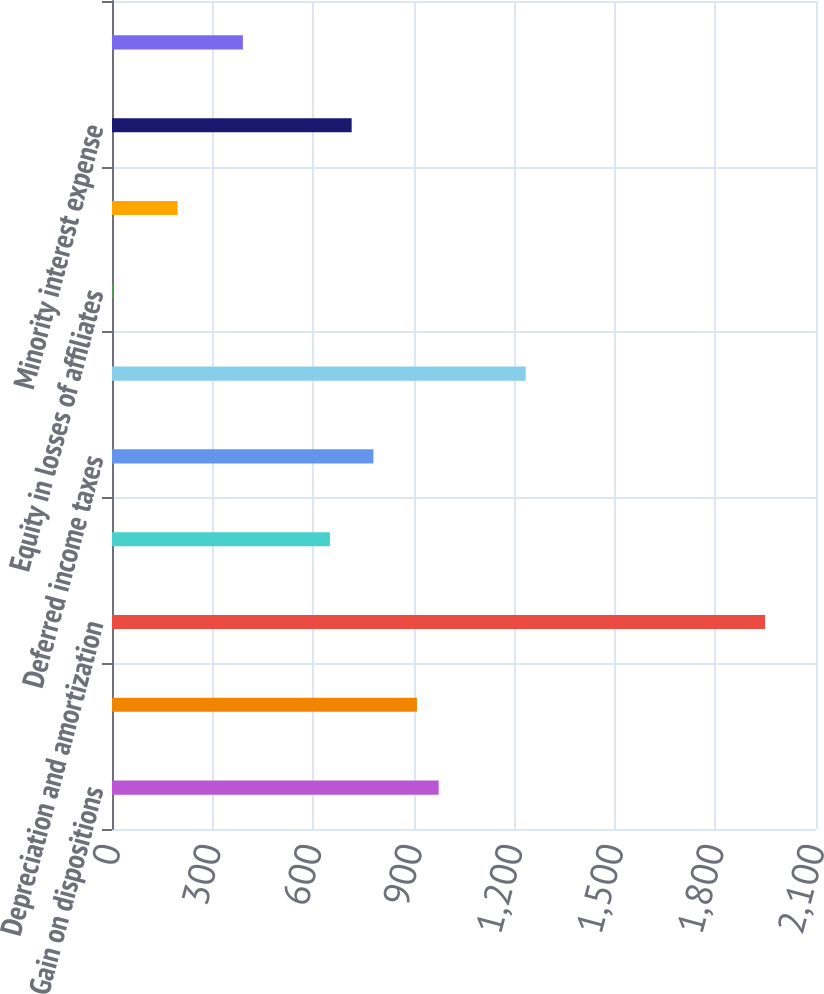Convert chart. <chart><loc_0><loc_0><loc_500><loc_500><bar_chart><fcel>Gain on dispositions<fcel>Depreciation<fcel>Depreciation and amortization<fcel>Amortization of deferred<fcel>Deferred income taxes<fcel>Net gains on property<fcel>Equity in losses of affiliates<fcel>Distributions from equity<fcel>Minority interest expense<fcel>Change in due from managers<nl><fcel>974.5<fcel>909.6<fcel>1948<fcel>650<fcel>779.8<fcel>1234.1<fcel>1<fcel>195.7<fcel>714.9<fcel>390.4<nl></chart> 